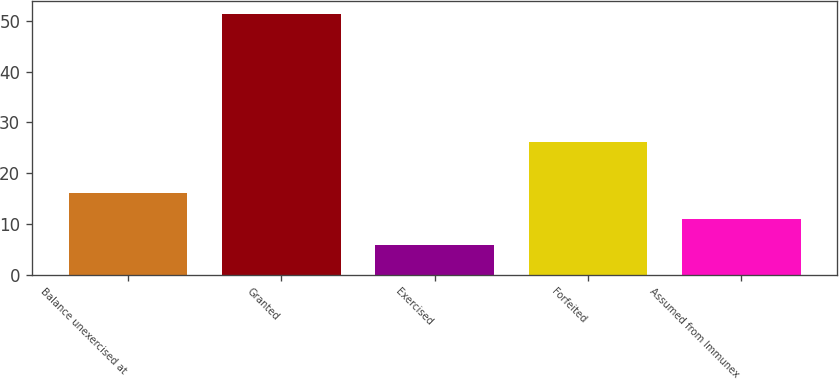Convert chart to OTSL. <chart><loc_0><loc_0><loc_500><loc_500><bar_chart><fcel>Balance unexercised at<fcel>Granted<fcel>Exercised<fcel>Forfeited<fcel>Assumed from Immunex<nl><fcel>16.04<fcel>51.31<fcel>5.96<fcel>26.12<fcel>11<nl></chart> 